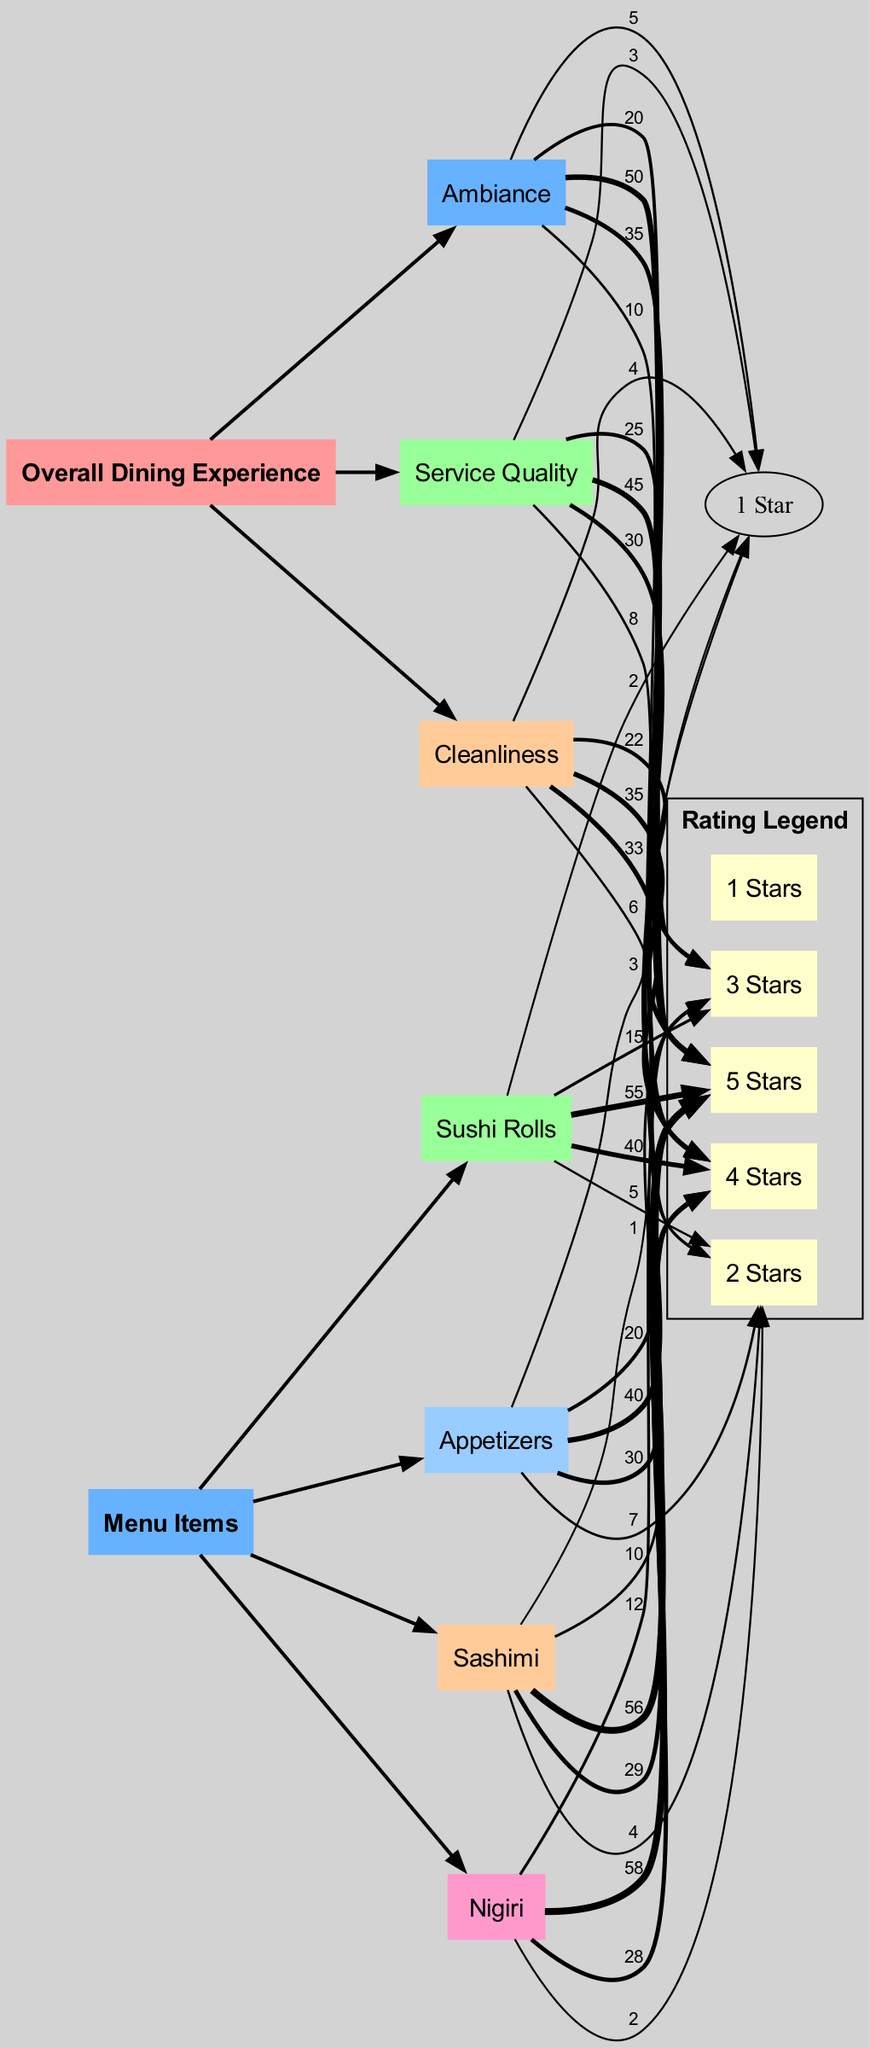What is the total number of 5-star ratings for Sashimi? The 5-star ratings for Sashimi are 56, which is shown as a direct connection from the Sashimi node to the 5 Stars node in the diagram.
Answer: 56 Which menu item received the lowest total ratings? By examining the total ratings for each menu item, we find that Nigiri has the lowest total with 0 1-star ratings and 2 2-star ratings, making it less favorable overall.
Answer: Nigiri What is the highest rated aspect of Overall Dining Experience? The Ambiance was rated 5 stars the most, with 50 counts indicated on the diagram. This indicates that Ambiance has the highest rating compared to Service Quality and Cleanliness.
Answer: Ambiance How many total subcategories are present in the diagram? There are 6 subcategories; 3 under Overall Dining Experience and 4 under Menu Items, which can be counted directly from the nodes in the diagram.
Answer: 6 What is the total number of ratings for Appetizers? The total ratings for Appetizers can be calculated by summing the individual ratings (3+7+20+30+40) which gives us 100 total ratings, shown by the connection to the Appetizers node.
Answer: 100 Which dining experience aspect has the most 1-star ratings? Service Quality has the most 1-star ratings at 3, which can be deduced from the comparison of the 1-star ratings shown from each dining experience aspect in the diagram.
Answer: Service Quality Which menu item has the most total ratings? Sashimi has a total of 100 ratings (1+4+10+29+56), making it the menu item with the most ratings based on the connections and values in the diagram.
Answer: Sashimi What is the flow from Cleanliness to the highest rating? The flow shows that the Cleanliness aspect connects to the 5 Stars node with 35 counts. This helps trace the flow from Cleanliness to its highest rating.
Answer: 35 What is the total number of ratings for all the categories combined? By adding up all the ratings from each subcategory in the categories Overall Dining Experience and Menu Items, the grand total comes to 314. This total can be visually assessed by calculating the counts linked to each node.
Answer: 314 